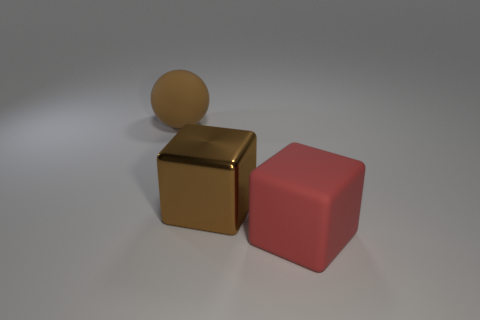Add 1 big shiny cylinders. How many objects exist? 4 Subtract all cubes. How many objects are left? 1 Subtract all brown rubber objects. Subtract all large brown matte spheres. How many objects are left? 1 Add 3 matte objects. How many matte objects are left? 5 Add 1 big red rubber objects. How many big red rubber objects exist? 2 Subtract 0 blue blocks. How many objects are left? 3 